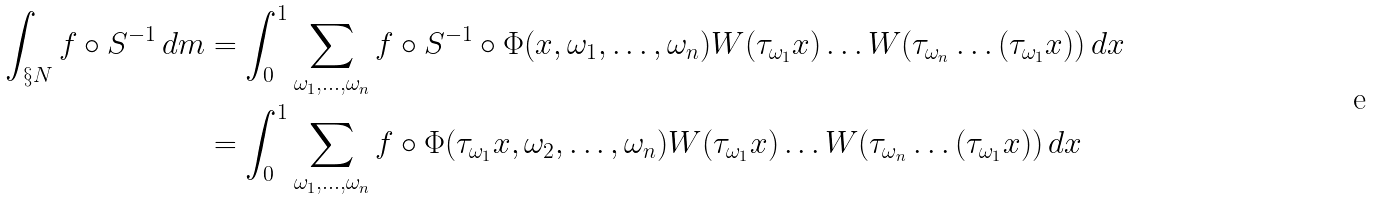<formula> <loc_0><loc_0><loc_500><loc_500>\int _ { \S N } f \circ S ^ { - 1 } \, d m & = \int _ { 0 } ^ { 1 } \sum _ { \omega _ { 1 } , \dots , \omega _ { n } } f \circ S ^ { - 1 } \circ \Phi ( x , \omega _ { 1 } , \dots , \omega _ { n } ) W ( \tau _ { \omega _ { 1 } } x ) \dots W ( \tau _ { \omega _ { n } } \dots ( \tau _ { \omega _ { 1 } } x ) ) \, d x \\ & = \int _ { 0 } ^ { 1 } \sum _ { \omega _ { 1 } , \dots , \omega _ { n } } f \circ \Phi ( \tau _ { \omega _ { 1 } } x , \omega _ { 2 } , \dots , \omega _ { n } ) W ( \tau _ { \omega _ { 1 } } x ) \dots W ( \tau _ { \omega _ { n } } \dots ( \tau _ { \omega _ { 1 } } x ) ) \, d x \\</formula> 